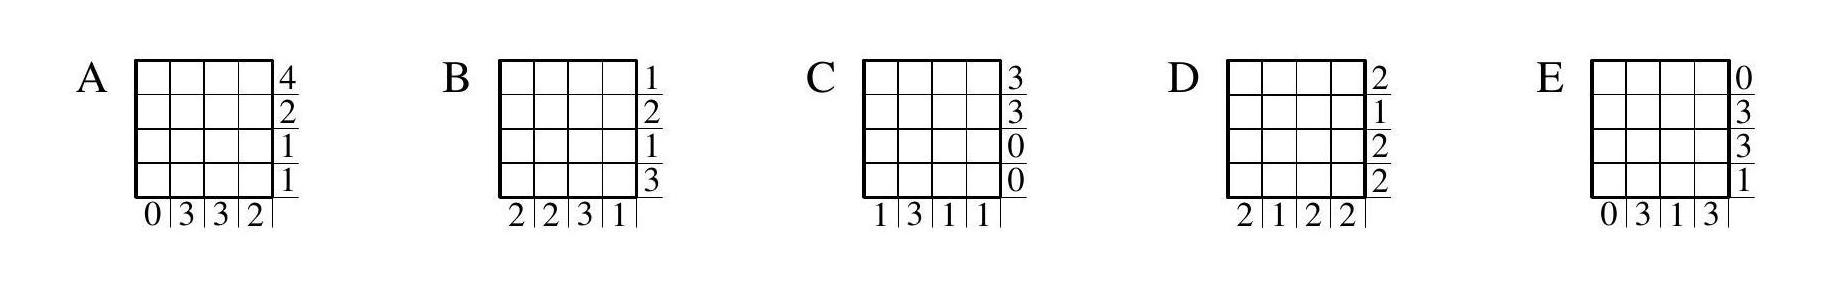If Patricia were to have painted the grid in a symmetrical pattern, which option would be most likely to represent that scenario? A symmetrical pattern of painted cells would manifest as mirrored counts across the corresponding rows and columns. Among the choices, option C hints at a symmetrical pattern with its center-most columns and middle rows having identical counts. However, the outer rows and columns contradict the symmetry. Thus, while it's the closest to representing symmetry, it is still not an accurate representation of a fully symmetrical painting pattern. 